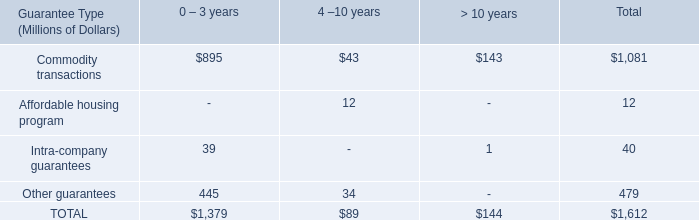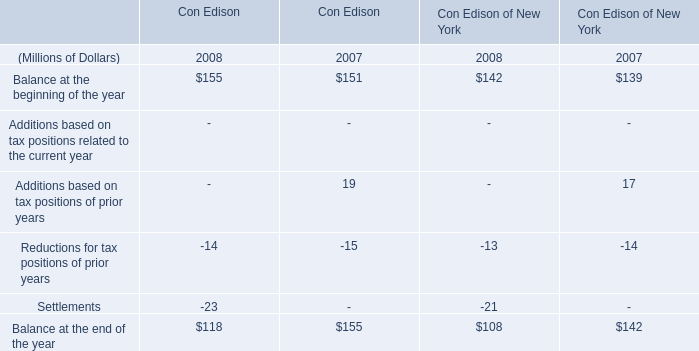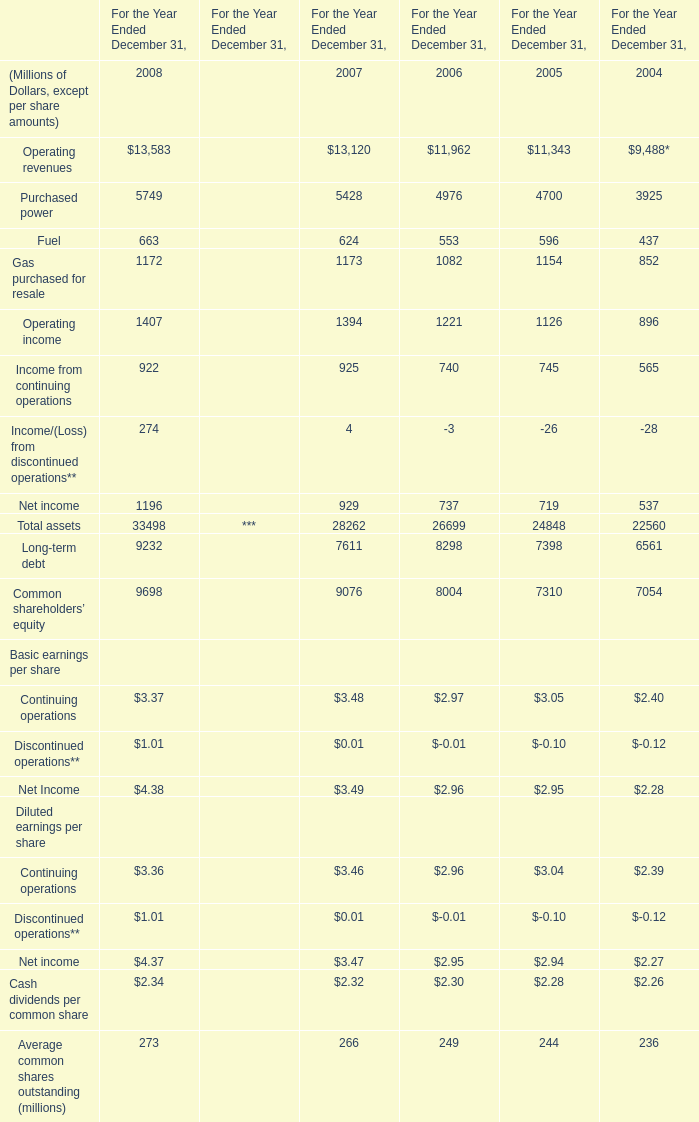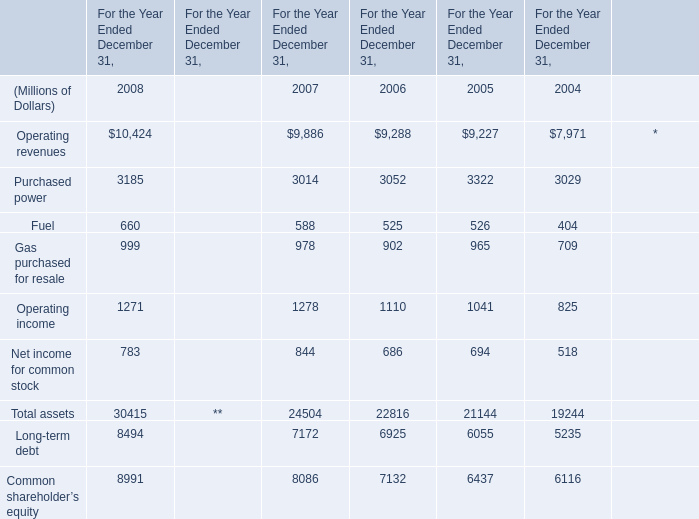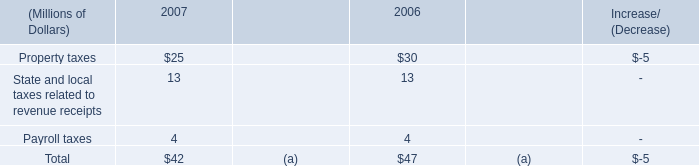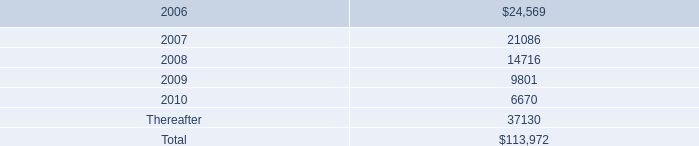what's the total amount of TOTAL of 0 – 3 years, Operating income of For the Year Ended December 31, 2007, and Operating revenues of For the Year Ended December 31, 2007 ? 
Computations: ((1379.0 + 1278.0) + 9886.0)
Answer: 12543.0. 